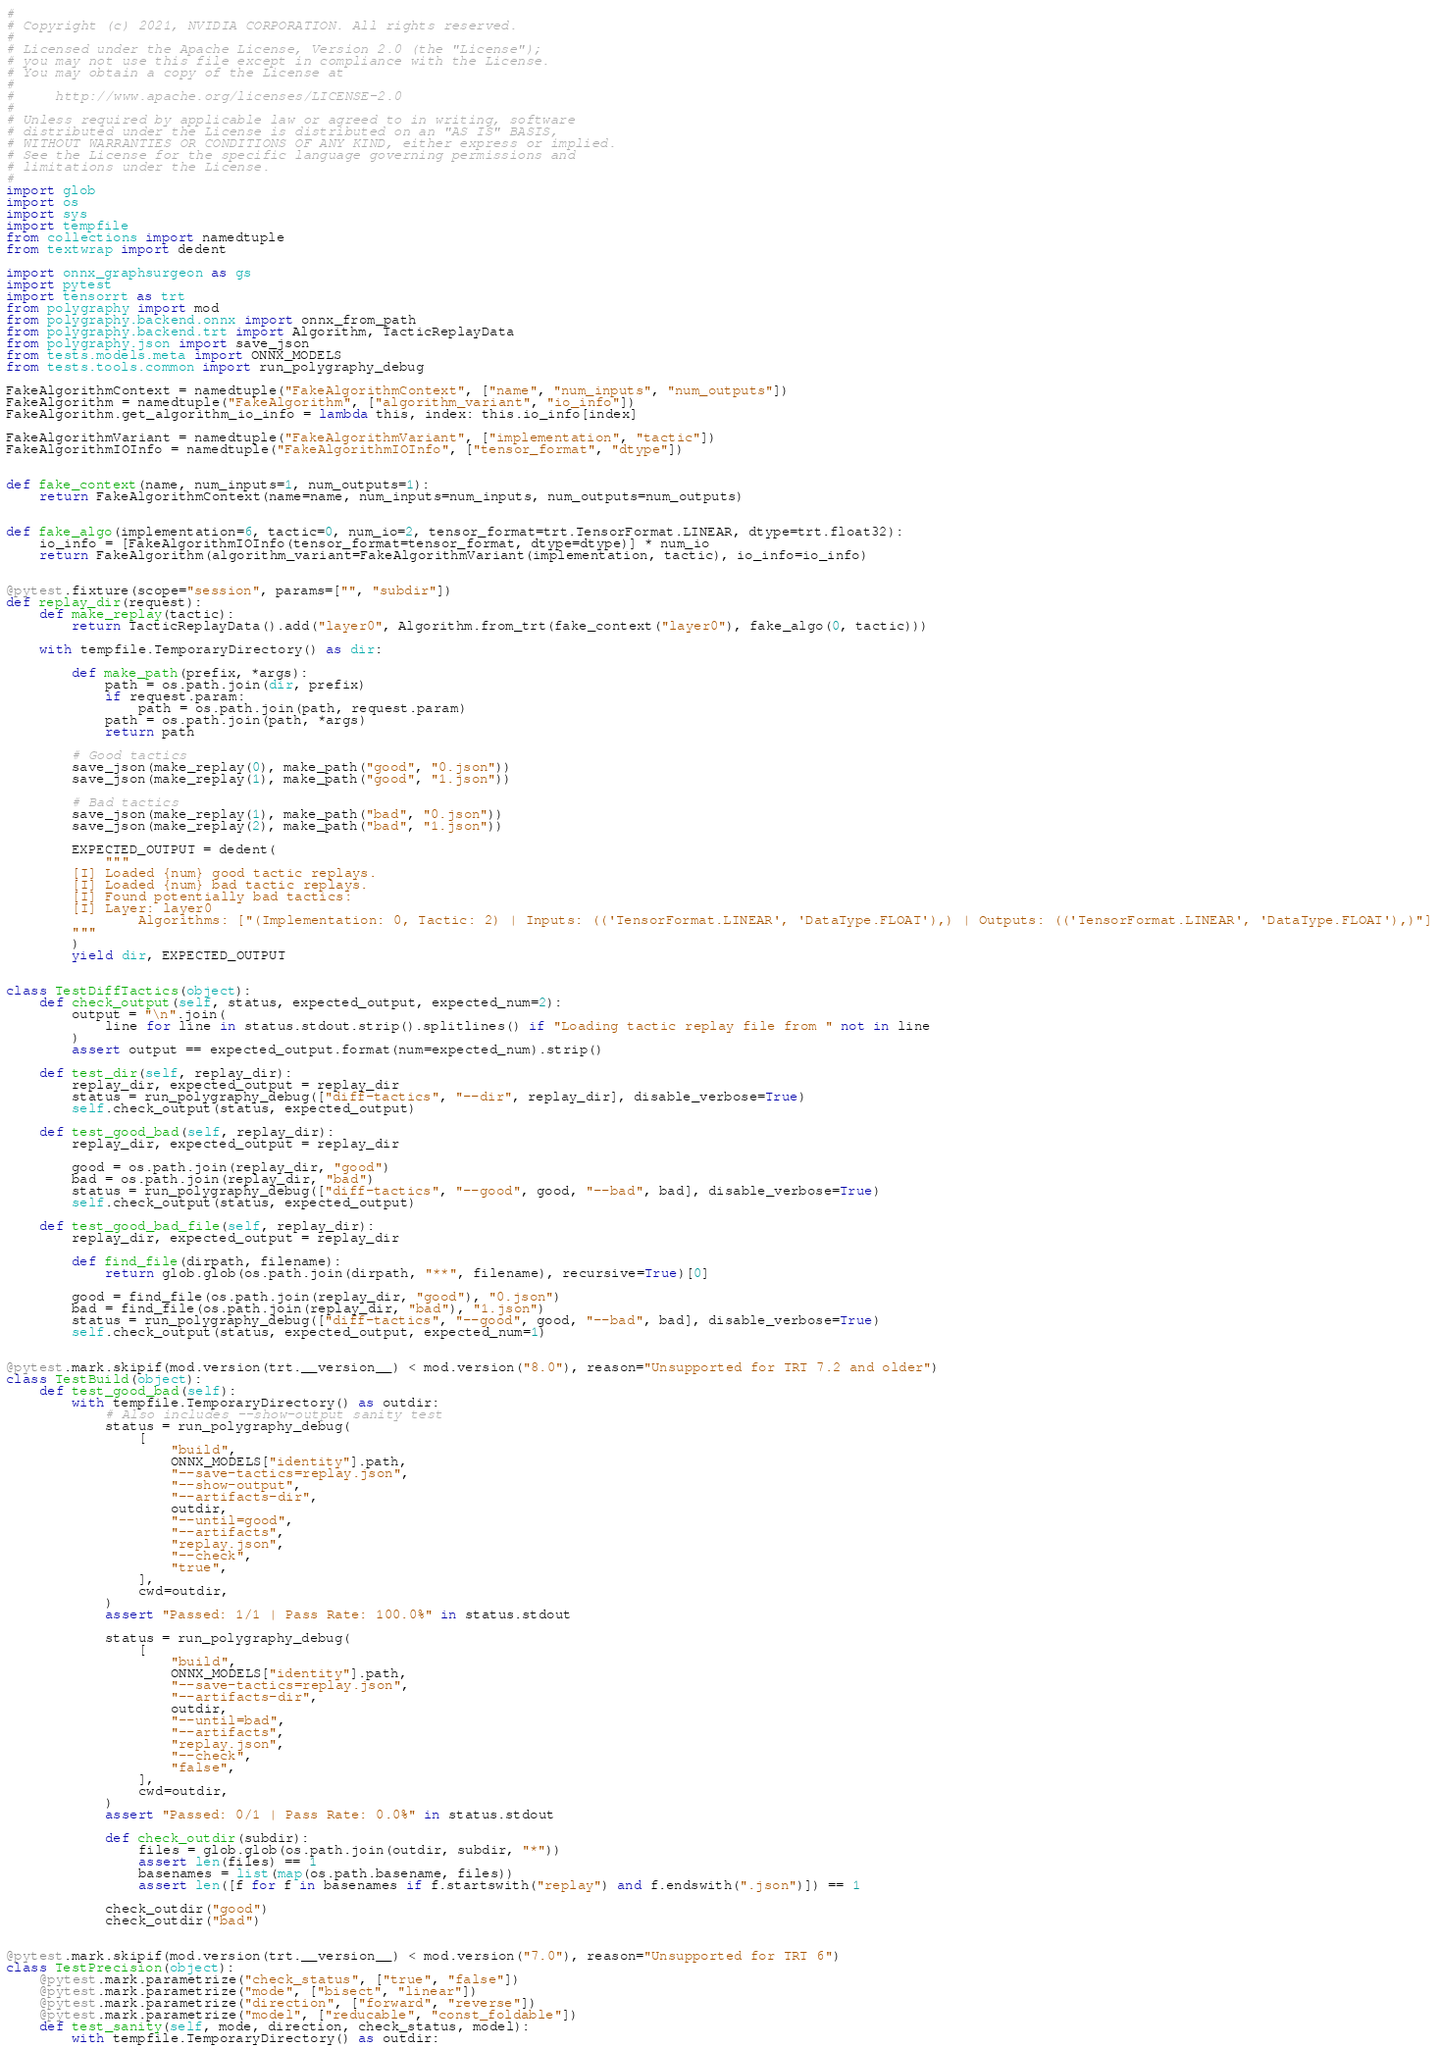Convert code to text. <code><loc_0><loc_0><loc_500><loc_500><_Python_>#
# Copyright (c) 2021, NVIDIA CORPORATION. All rights reserved.
#
# Licensed under the Apache License, Version 2.0 (the "License");
# you may not use this file except in compliance with the License.
# You may obtain a copy of the License at
#
#     http://www.apache.org/licenses/LICENSE-2.0
#
# Unless required by applicable law or agreed to in writing, software
# distributed under the License is distributed on an "AS IS" BASIS,
# WITHOUT WARRANTIES OR CONDITIONS OF ANY KIND, either express or implied.
# See the License for the specific language governing permissions and
# limitations under the License.
#
import glob
import os
import sys
import tempfile
from collections import namedtuple
from textwrap import dedent

import onnx_graphsurgeon as gs
import pytest
import tensorrt as trt
from polygraphy import mod
from polygraphy.backend.onnx import onnx_from_path
from polygraphy.backend.trt import Algorithm, TacticReplayData
from polygraphy.json import save_json
from tests.models.meta import ONNX_MODELS
from tests.tools.common import run_polygraphy_debug

FakeAlgorithmContext = namedtuple("FakeAlgorithmContext", ["name", "num_inputs", "num_outputs"])
FakeAlgorithm = namedtuple("FakeAlgorithm", ["algorithm_variant", "io_info"])
FakeAlgorithm.get_algorithm_io_info = lambda this, index: this.io_info[index]

FakeAlgorithmVariant = namedtuple("FakeAlgorithmVariant", ["implementation", "tactic"])
FakeAlgorithmIOInfo = namedtuple("FakeAlgorithmIOInfo", ["tensor_format", "dtype"])


def fake_context(name, num_inputs=1, num_outputs=1):
    return FakeAlgorithmContext(name=name, num_inputs=num_inputs, num_outputs=num_outputs)


def fake_algo(implementation=6, tactic=0, num_io=2, tensor_format=trt.TensorFormat.LINEAR, dtype=trt.float32):
    io_info = [FakeAlgorithmIOInfo(tensor_format=tensor_format, dtype=dtype)] * num_io
    return FakeAlgorithm(algorithm_variant=FakeAlgorithmVariant(implementation, tactic), io_info=io_info)


@pytest.fixture(scope="session", params=["", "subdir"])
def replay_dir(request):
    def make_replay(tactic):
        return TacticReplayData().add("layer0", Algorithm.from_trt(fake_context("layer0"), fake_algo(0, tactic)))

    with tempfile.TemporaryDirectory() as dir:

        def make_path(prefix, *args):
            path = os.path.join(dir, prefix)
            if request.param:
                path = os.path.join(path, request.param)
            path = os.path.join(path, *args)
            return path

        # Good tactics
        save_json(make_replay(0), make_path("good", "0.json"))
        save_json(make_replay(1), make_path("good", "1.json"))

        # Bad tactics
        save_json(make_replay(1), make_path("bad", "0.json"))
        save_json(make_replay(2), make_path("bad", "1.json"))

        EXPECTED_OUTPUT = dedent(
            """
        [I] Loaded {num} good tactic replays.
        [I] Loaded {num} bad tactic replays.
        [I] Found potentially bad tactics:
        [I] Layer: layer0
                Algorithms: ["(Implementation: 0, Tactic: 2) | Inputs: (('TensorFormat.LINEAR', 'DataType.FLOAT'),) | Outputs: (('TensorFormat.LINEAR', 'DataType.FLOAT'),)"]
        """
        )
        yield dir, EXPECTED_OUTPUT


class TestDiffTactics(object):
    def check_output(self, status, expected_output, expected_num=2):
        output = "\n".join(
            line for line in status.stdout.strip().splitlines() if "Loading tactic replay file from " not in line
        )
        assert output == expected_output.format(num=expected_num).strip()

    def test_dir(self, replay_dir):
        replay_dir, expected_output = replay_dir
        status = run_polygraphy_debug(["diff-tactics", "--dir", replay_dir], disable_verbose=True)
        self.check_output(status, expected_output)

    def test_good_bad(self, replay_dir):
        replay_dir, expected_output = replay_dir

        good = os.path.join(replay_dir, "good")
        bad = os.path.join(replay_dir, "bad")
        status = run_polygraphy_debug(["diff-tactics", "--good", good, "--bad", bad], disable_verbose=True)
        self.check_output(status, expected_output)

    def test_good_bad_file(self, replay_dir):
        replay_dir, expected_output = replay_dir

        def find_file(dirpath, filename):
            return glob.glob(os.path.join(dirpath, "**", filename), recursive=True)[0]

        good = find_file(os.path.join(replay_dir, "good"), "0.json")
        bad = find_file(os.path.join(replay_dir, "bad"), "1.json")
        status = run_polygraphy_debug(["diff-tactics", "--good", good, "--bad", bad], disable_verbose=True)
        self.check_output(status, expected_output, expected_num=1)


@pytest.mark.skipif(mod.version(trt.__version__) < mod.version("8.0"), reason="Unsupported for TRT 7.2 and older")
class TestBuild(object):
    def test_good_bad(self):
        with tempfile.TemporaryDirectory() as outdir:
            # Also includes --show-output sanity test
            status = run_polygraphy_debug(
                [
                    "build",
                    ONNX_MODELS["identity"].path,
                    "--save-tactics=replay.json",
                    "--show-output",
                    "--artifacts-dir",
                    outdir,
                    "--until=good",
                    "--artifacts",
                    "replay.json",
                    "--check",
                    "true",
                ],
                cwd=outdir,
            )
            assert "Passed: 1/1 | Pass Rate: 100.0%" in status.stdout

            status = run_polygraphy_debug(
                [
                    "build",
                    ONNX_MODELS["identity"].path,
                    "--save-tactics=replay.json",
                    "--artifacts-dir",
                    outdir,
                    "--until=bad",
                    "--artifacts",
                    "replay.json",
                    "--check",
                    "false",
                ],
                cwd=outdir,
            )
            assert "Passed: 0/1 | Pass Rate: 0.0%" in status.stdout

            def check_outdir(subdir):
                files = glob.glob(os.path.join(outdir, subdir, "*"))
                assert len(files) == 1
                basenames = list(map(os.path.basename, files))
                assert len([f for f in basenames if f.startswith("replay") and f.endswith(".json")]) == 1

            check_outdir("good")
            check_outdir("bad")


@pytest.mark.skipif(mod.version(trt.__version__) < mod.version("7.0"), reason="Unsupported for TRT 6")
class TestPrecision(object):
    @pytest.mark.parametrize("check_status", ["true", "false"])
    @pytest.mark.parametrize("mode", ["bisect", "linear"])
    @pytest.mark.parametrize("direction", ["forward", "reverse"])
    @pytest.mark.parametrize("model", ["reducable", "const_foldable"])
    def test_sanity(self, mode, direction, check_status, model):
        with tempfile.TemporaryDirectory() as outdir:</code> 